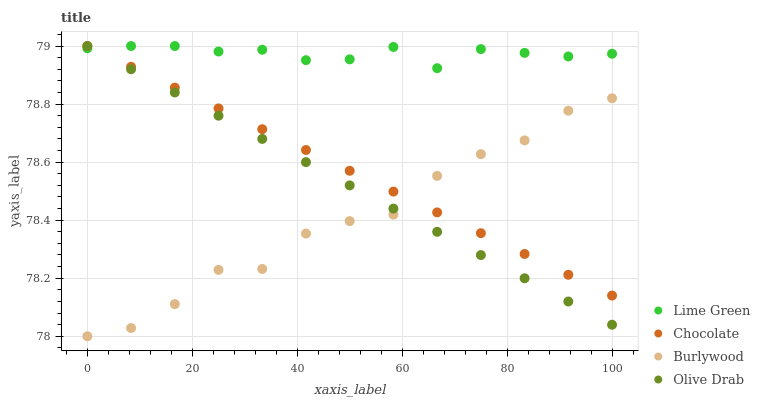Does Burlywood have the minimum area under the curve?
Answer yes or no. Yes. Does Lime Green have the maximum area under the curve?
Answer yes or no. Yes. Does Olive Drab have the minimum area under the curve?
Answer yes or no. No. Does Olive Drab have the maximum area under the curve?
Answer yes or no. No. Is Olive Drab the smoothest?
Answer yes or no. Yes. Is Burlywood the roughest?
Answer yes or no. Yes. Is Lime Green the smoothest?
Answer yes or no. No. Is Lime Green the roughest?
Answer yes or no. No. Does Burlywood have the lowest value?
Answer yes or no. Yes. Does Olive Drab have the lowest value?
Answer yes or no. No. Does Chocolate have the highest value?
Answer yes or no. Yes. Is Burlywood less than Lime Green?
Answer yes or no. Yes. Is Lime Green greater than Burlywood?
Answer yes or no. Yes. Does Olive Drab intersect Burlywood?
Answer yes or no. Yes. Is Olive Drab less than Burlywood?
Answer yes or no. No. Is Olive Drab greater than Burlywood?
Answer yes or no. No. Does Burlywood intersect Lime Green?
Answer yes or no. No. 